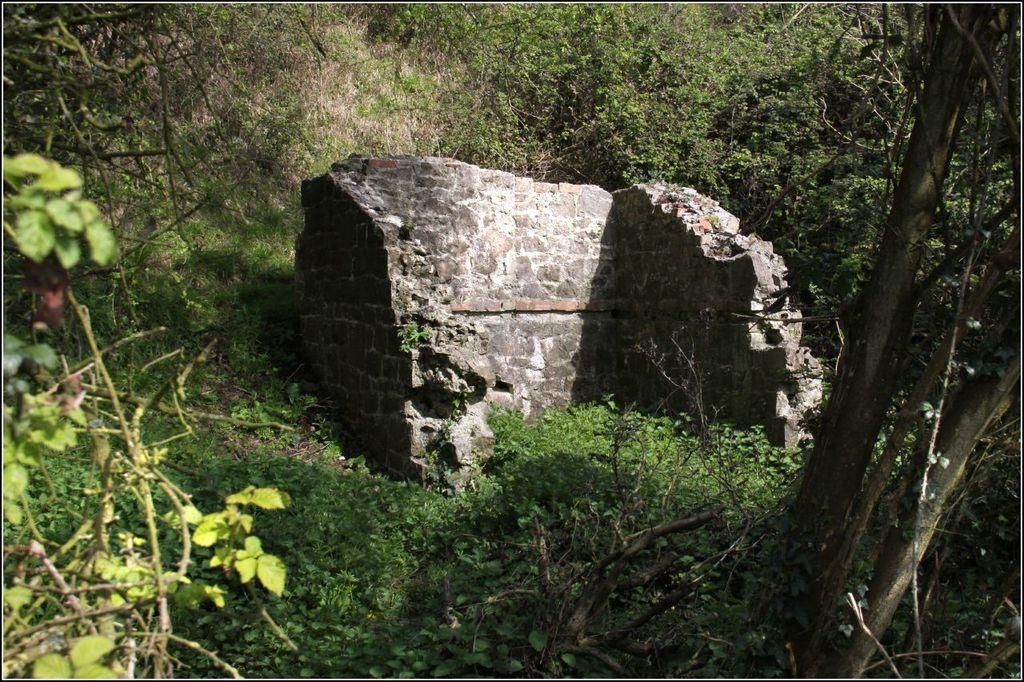What is the main structure in the center of the image? There is a wall in the center of the image. What type of vegetation is present around the wall? There are plants and trees around the wall. What is the condition of the approval for the agreement in the image? There is no mention of approval or agreement in the image; it only features a wall with plants and trees around it. 